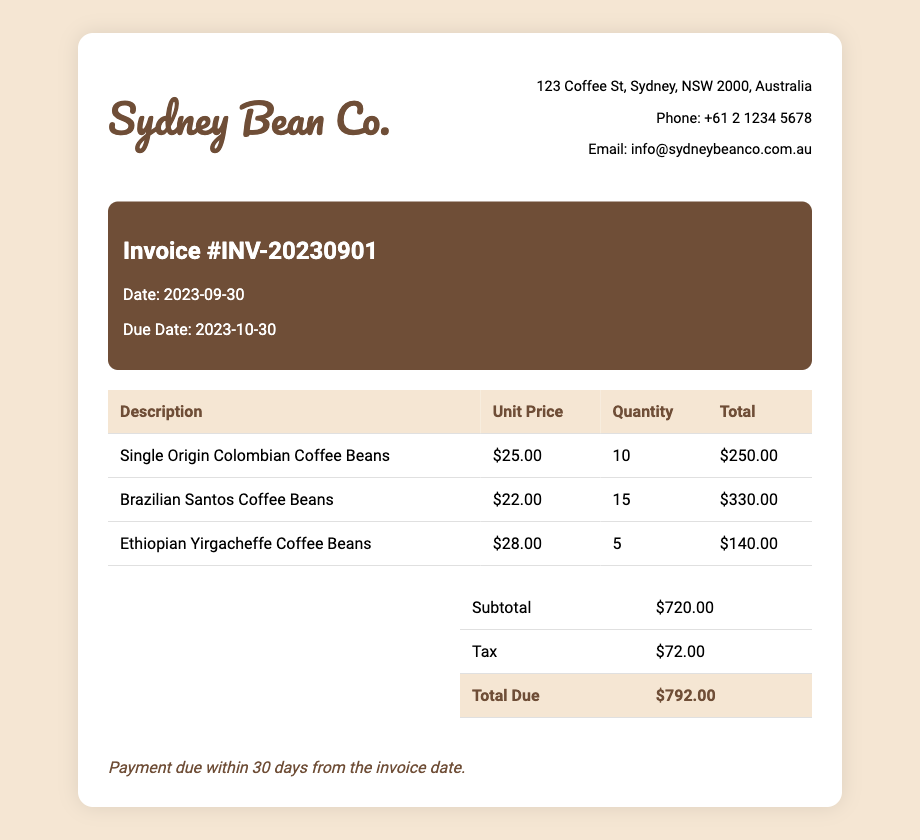What is the invoice number? The invoice number is listed at the top of the document under the invoice details section.
Answer: INV-20230901 What is the total due amount? The total due amount is stated in the summary table at the end of the document.
Answer: $792.00 What is the unit price of Ethiopian Yirgacheffe Coffee Beans? The unit price is found in the table that lists the items purchased, specifically under the unit price column.
Answer: $28.00 How many quantities of Brazilian Santos Coffee Beans were purchased? The quantity can be found in the table under the quantity column for Brazilian Santos Coffee Beans.
Answer: 15 What is the due date for this invoice? The due date for the invoice is specified in the invoice details section in the document.
Answer: 2023-10-30 What is the subtotal before tax? The subtotal is noted in the summary table prior to the tax calculation.
Answer: $720.00 What is the tax amount applied to this invoice? The tax amount is detailed in the summary table at the bottom of the document.
Answer: $72.00 What is the supplier's phone number? The supplier's phone number is listed in the supplier information section of the document.
Answer: +61 2 1234 5678 What is the payment term stated in the invoice? The payment term can be found at the bottom of the invoice, providing instructions regarding payment.
Answer: Payment due within 30 days from the invoice date 